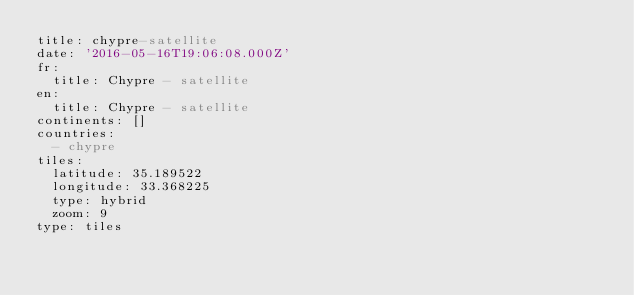Convert code to text. <code><loc_0><loc_0><loc_500><loc_500><_YAML_>title: chypre-satellite
date: '2016-05-16T19:06:08.000Z'
fr:
  title: Chypre - satellite
en:
  title: Chypre - satellite
continents: []
countries:
  - chypre
tiles:
  latitude: 35.189522
  longitude: 33.368225
  type: hybrid
  zoom: 9
type: tiles
</code> 